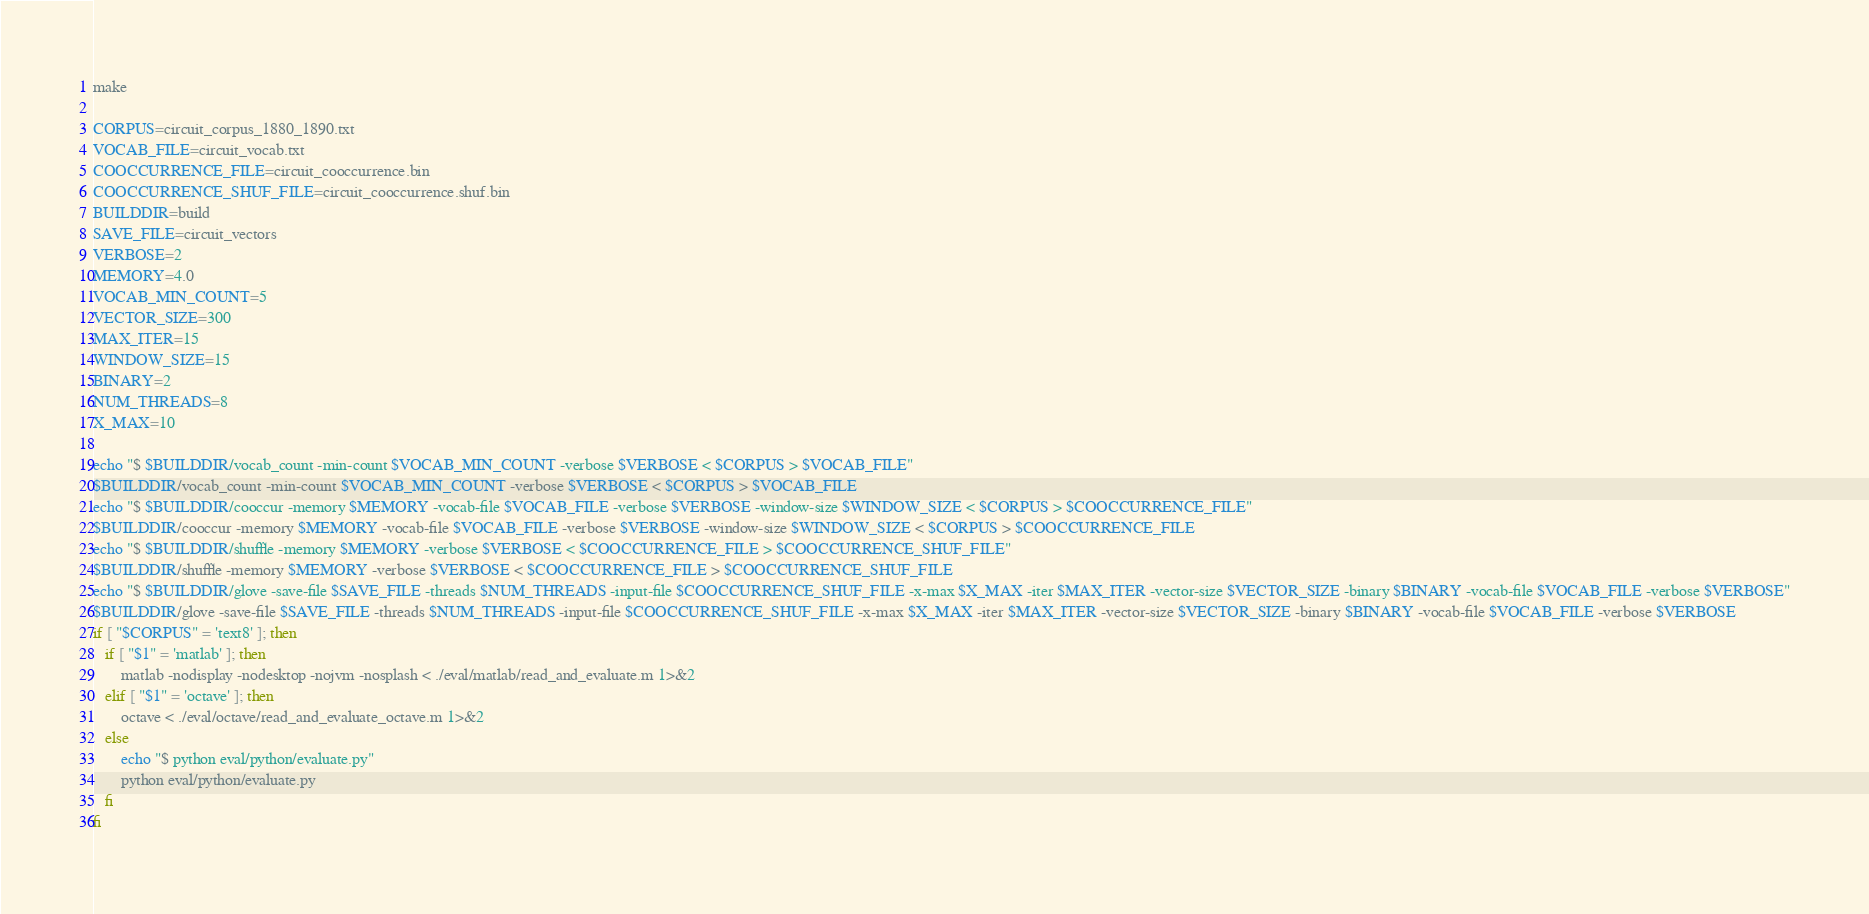Convert code to text. <code><loc_0><loc_0><loc_500><loc_500><_Bash_>make

CORPUS=circuit_corpus_1880_1890.txt
VOCAB_FILE=circuit_vocab.txt
COOCCURRENCE_FILE=circuit_cooccurrence.bin
COOCCURRENCE_SHUF_FILE=circuit_cooccurrence.shuf.bin
BUILDDIR=build
SAVE_FILE=circuit_vectors
VERBOSE=2
MEMORY=4.0
VOCAB_MIN_COUNT=5
VECTOR_SIZE=300
MAX_ITER=15
WINDOW_SIZE=15
BINARY=2
NUM_THREADS=8
X_MAX=10

echo "$ $BUILDDIR/vocab_count -min-count $VOCAB_MIN_COUNT -verbose $VERBOSE < $CORPUS > $VOCAB_FILE"
$BUILDDIR/vocab_count -min-count $VOCAB_MIN_COUNT -verbose $VERBOSE < $CORPUS > $VOCAB_FILE
echo "$ $BUILDDIR/cooccur -memory $MEMORY -vocab-file $VOCAB_FILE -verbose $VERBOSE -window-size $WINDOW_SIZE < $CORPUS > $COOCCURRENCE_FILE"
$BUILDDIR/cooccur -memory $MEMORY -vocab-file $VOCAB_FILE -verbose $VERBOSE -window-size $WINDOW_SIZE < $CORPUS > $COOCCURRENCE_FILE
echo "$ $BUILDDIR/shuffle -memory $MEMORY -verbose $VERBOSE < $COOCCURRENCE_FILE > $COOCCURRENCE_SHUF_FILE"
$BUILDDIR/shuffle -memory $MEMORY -verbose $VERBOSE < $COOCCURRENCE_FILE > $COOCCURRENCE_SHUF_FILE
echo "$ $BUILDDIR/glove -save-file $SAVE_FILE -threads $NUM_THREADS -input-file $COOCCURRENCE_SHUF_FILE -x-max $X_MAX -iter $MAX_ITER -vector-size $VECTOR_SIZE -binary $BINARY -vocab-file $VOCAB_FILE -verbose $VERBOSE"
$BUILDDIR/glove -save-file $SAVE_FILE -threads $NUM_THREADS -input-file $COOCCURRENCE_SHUF_FILE -x-max $X_MAX -iter $MAX_ITER -vector-size $VECTOR_SIZE -binary $BINARY -vocab-file $VOCAB_FILE -verbose $VERBOSE
if [ "$CORPUS" = 'text8' ]; then
   if [ "$1" = 'matlab' ]; then
       matlab -nodisplay -nodesktop -nojvm -nosplash < ./eval/matlab/read_and_evaluate.m 1>&2 
   elif [ "$1" = 'octave' ]; then
       octave < ./eval/octave/read_and_evaluate_octave.m 1>&2
   else
       echo "$ python eval/python/evaluate.py"
       python eval/python/evaluate.py
   fi
fi
</code> 